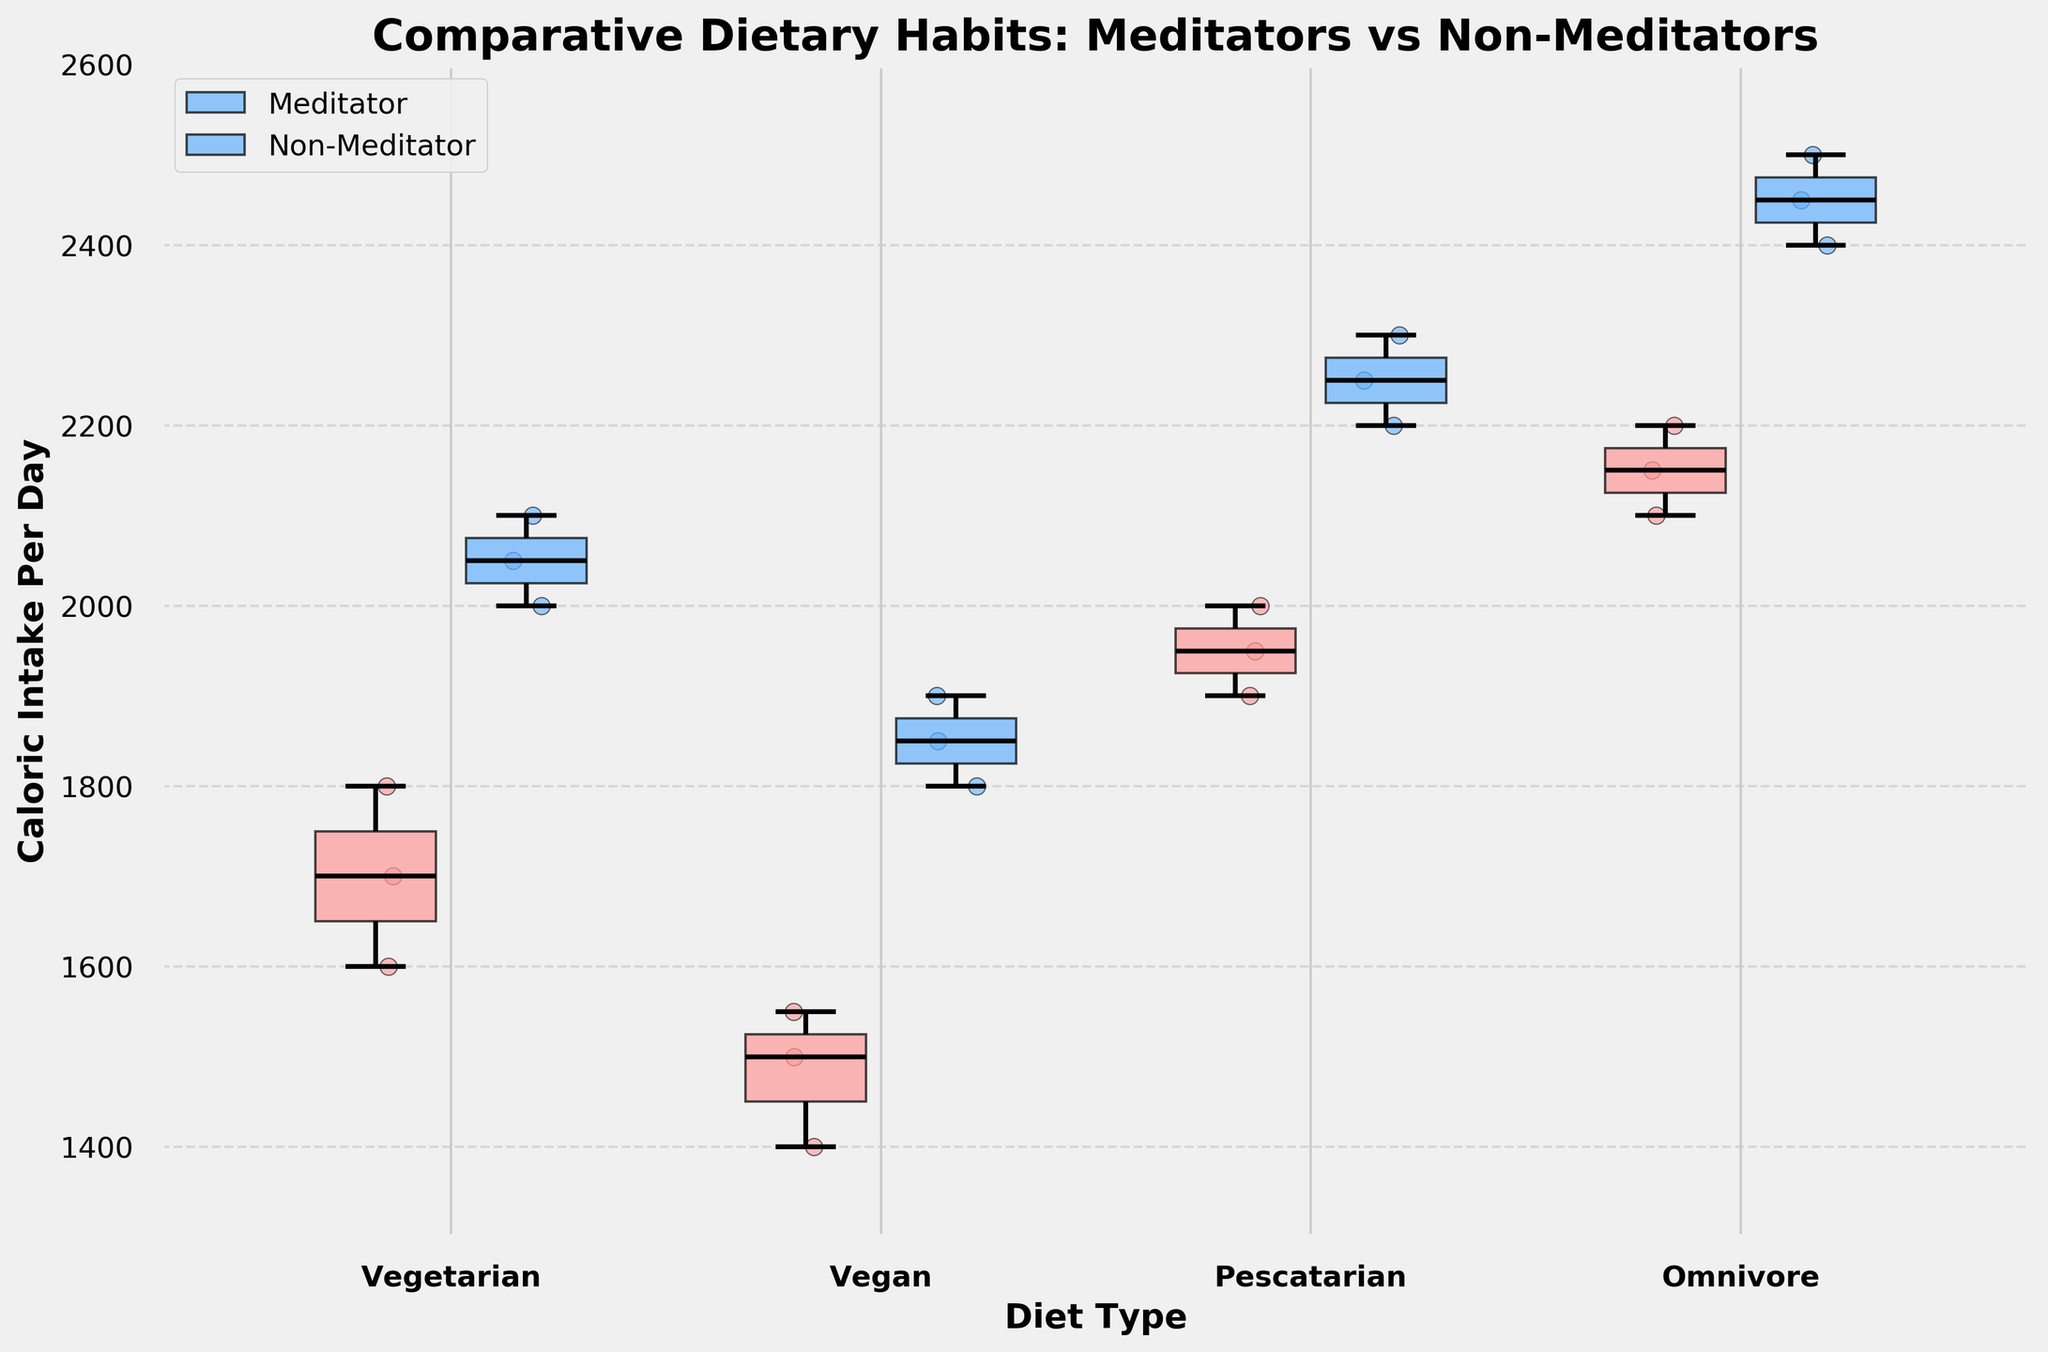How are the diet types categorized on the x-axis? The x-axis categorizes the diet types as Vegetarian, Vegan, Pescatarian, and Omnivore based on the dietary habits of the individuals.
Answer: Vegetarian, Vegan, Pescatarian, Omnivore Which group has the highest median caloric intake for Omnivore diet type? To find this, compare the median lines (black lines) within each box for the Omnivore diet type. The Non-Meditators have a higher median caloric intake than Meditators.
Answer: Non-Meditators What's the title of the graph? The title of the graph is displayed prominently at the top and describes the overall purpose of the figure. It is "Comparative Dietary Habits: Meditators vs Non-Meditators".
Answer: Comparative Dietary Habits: Meditators vs Non-Meditators How does the median caloric intake of Vegan diet type compare between Meditators and Non-Meditators? By examining the median lines of the Vegan diet type, it's apparent that the median caloric intake for Non-Meditators is higher than for Meditators.
Answer: Non-Meditators median is higher For the Vegetarian diet type, are the data points more scattered for Meditators or Non-Meditators? Scatter points indicate variability. In the Vegetarian diet type, the scatter points are more spread out (scattered) for Non-Meditators than Meditators.
Answer: Non-Meditators Which group has the narrowest interquartile range (IQR) for the Vegan diet type? The IQR is the range between the first and third quartiles of the box plot. Comparing the Vegan diet types, Meditators have a narrower IQR than Non-Meditators.
Answer: Meditators What is the approximate caloric intake range for Pescatarian Meditators? The range can be estimated by looking at the ends of the whiskers in the box plot for Pescatarian Meditators. The approximate range is from 1900 to 2000.
Answer: 1900 to 2000 Between which two diet types is the caloric intake variation the greatest for Non-Meditators? For Non-Meditators, the variation can be judged by the length of the whiskers. The greatest variation appears to be between Vegan and Omnivore diet types.
Answer: Vegan and Omnivore Which group appears to have more consistent caloric intake across all diet types? By observing the consistency (less spread of data points) across all diet types, Meditators show more consistent caloric intake as compared to Non-Meditators.
Answer: Meditators 